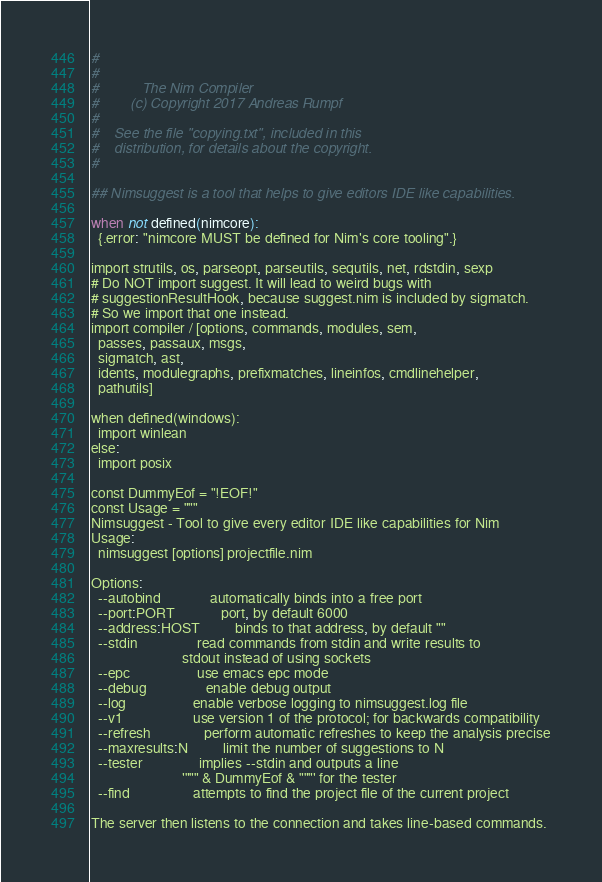Convert code to text. <code><loc_0><loc_0><loc_500><loc_500><_Nim_>#
#
#           The Nim Compiler
#        (c) Copyright 2017 Andreas Rumpf
#
#    See the file "copying.txt", included in this
#    distribution, for details about the copyright.
#

## Nimsuggest is a tool that helps to give editors IDE like capabilities.

when not defined(nimcore):
  {.error: "nimcore MUST be defined for Nim's core tooling".}

import strutils, os, parseopt, parseutils, sequtils, net, rdstdin, sexp
# Do NOT import suggest. It will lead to weird bugs with
# suggestionResultHook, because suggest.nim is included by sigmatch.
# So we import that one instead.
import compiler / [options, commands, modules, sem,
  passes, passaux, msgs,
  sigmatch, ast,
  idents, modulegraphs, prefixmatches, lineinfos, cmdlinehelper,
  pathutils]

when defined(windows):
  import winlean
else:
  import posix

const DummyEof = "!EOF!"
const Usage = """
Nimsuggest - Tool to give every editor IDE like capabilities for Nim
Usage:
  nimsuggest [options] projectfile.nim

Options:
  --autobind              automatically binds into a free port
  --port:PORT             port, by default 6000
  --address:HOST          binds to that address, by default ""
  --stdin                 read commands from stdin and write results to
                          stdout instead of using sockets
  --epc                   use emacs epc mode
  --debug                 enable debug output
  --log                   enable verbose logging to nimsuggest.log file
  --v1                    use version 1 of the protocol; for backwards compatibility
  --refresh               perform automatic refreshes to keep the analysis precise
  --maxresults:N          limit the number of suggestions to N
  --tester                implies --stdin and outputs a line
                          '""" & DummyEof & """' for the tester
  --find                  attempts to find the project file of the current project

The server then listens to the connection and takes line-based commands.
</code> 